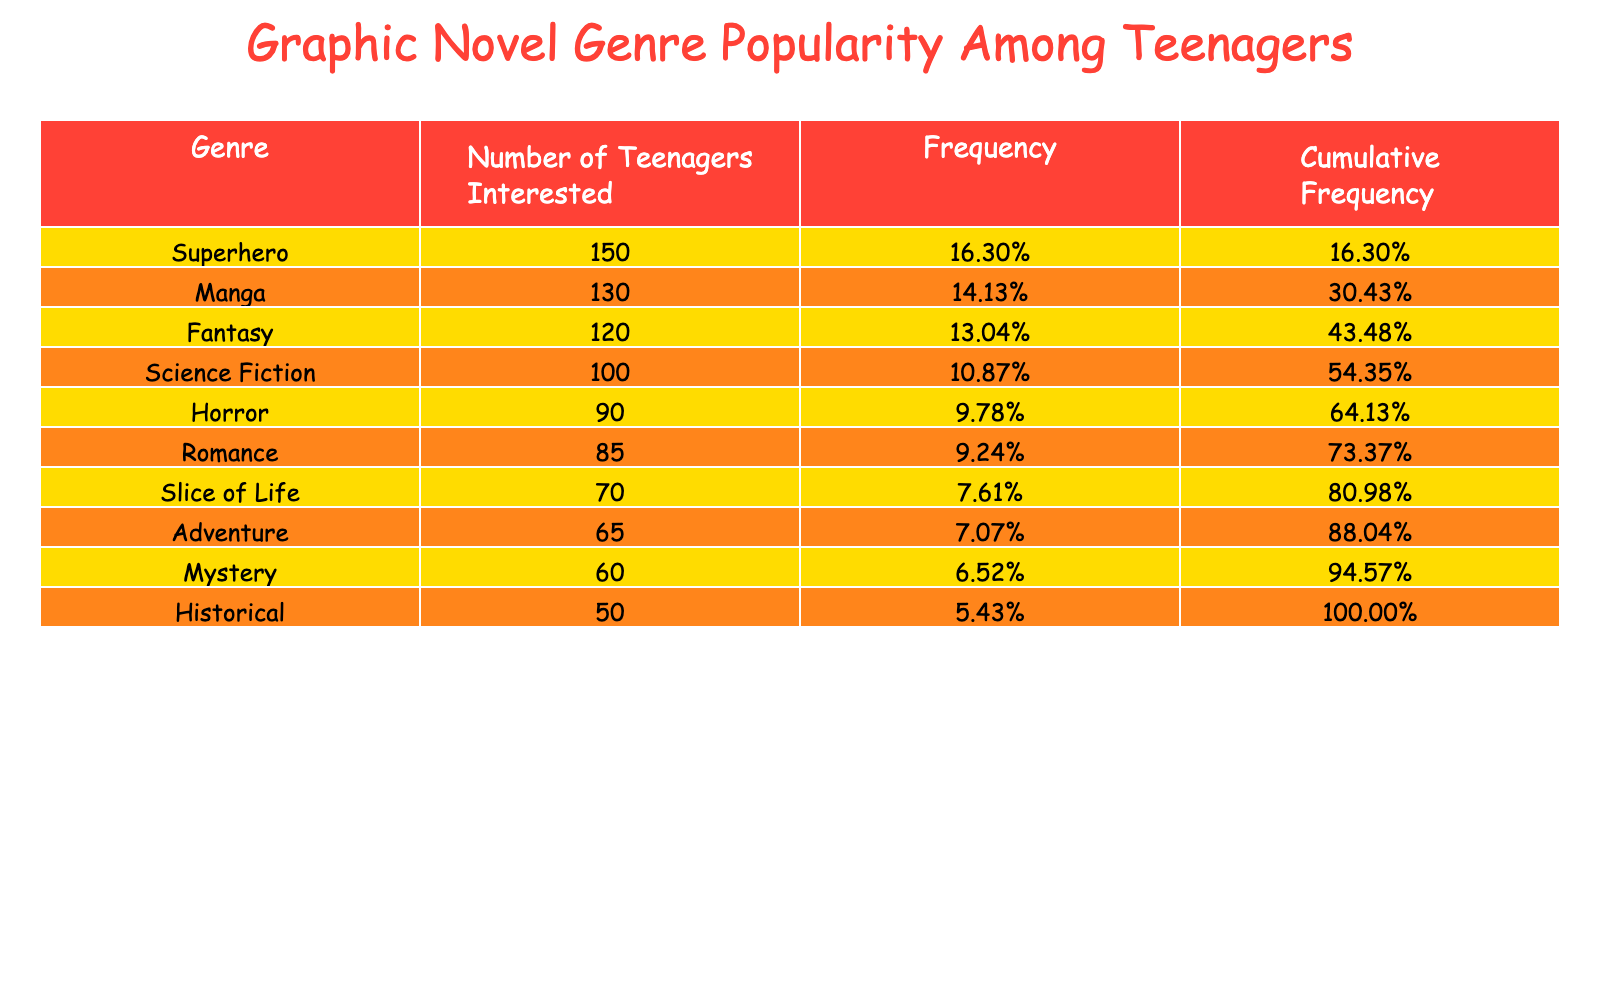What is the most popular graphic novel genre among teenagers? The table shows that the genre "Superhero" has the highest number of teenagers interested, with a value of 150.
Answer: Superhero How many teenagers are interested in the Romance genre? The table lists that 85 teenagers are interested in the Romance genre, which can be found directly in the corresponding row.
Answer: 85 Which genre has the least number of teenagers interested? By checking the table, "Historical" has the lowest number of teenagers interested, with a total of 50.
Answer: Historical What is the cumulative frequency of the Science Fiction genre? The cumulative frequency indicates the proportion of teenagers interested in Science Fiction and all preceding genres. Adding the frequencies for Superhero (150), Manga (130), Fantasy (120), and Science Fiction (100) gives a cumulative frequency of 150/1,060 + 130/1,060 + 120/1,060 + 100/1,060 = 600/1,060 = 56.6%.
Answer: 56.6% Are more teenagers interested in Horror than in Slice of Life? Checking the table, 90 teenagers are interested in Horror, while for Slice of Life, it's 70. Since 90 is greater than 70, the answer is yes.
Answer: Yes What percentage of teenagers are interested in the Adventure genre compared to the total number of teenagers interested in all genres? The number of teenagers interested in Adventure is 65. The total number of teenagers interested is the sum of all, which is 1,060. Thus, the percentage is (65/1,060) * 100 = 6.15%.
Answer: 6.15% What is the difference in the number of teenagers interested between the Fantasy genre and the Mystery genre? The table shows that 120 are interested in Fantasy and 60 in Mystery. To find the difference, we subtract: 120 - 60 = 60.
Answer: 60 Is Manga more popular than the combined interest of the Romance and Slice of Life genres? Manga has 130 interested teenagers. Romance has 85 and Slice of Life has 70. Adding Romance and Slice of Life gives: 85 + 70 = 155. Since 155 is greater than 130, the answer is no.
Answer: No 